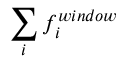Convert formula to latex. <formula><loc_0><loc_0><loc_500><loc_500>\sum _ { i } { f _ { i } ^ { w i n d o w } }</formula> 